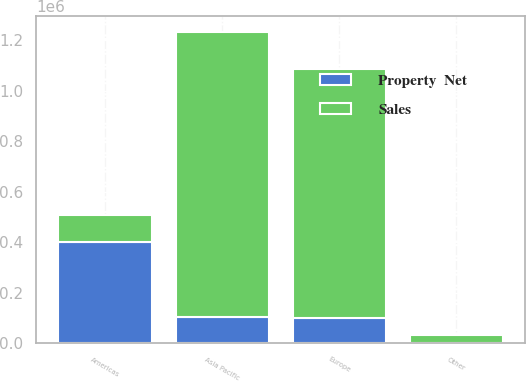<chart> <loc_0><loc_0><loc_500><loc_500><stacked_bar_chart><ecel><fcel>Americas<fcel>Asia Pacific<fcel>Europe<fcel>Other<nl><fcel>Sales<fcel>104305<fcel>1.1296e+06<fcel>987016<fcel>28988<nl><fcel>Property  Net<fcel>402370<fcel>104305<fcel>99835<fcel>1178<nl></chart> 